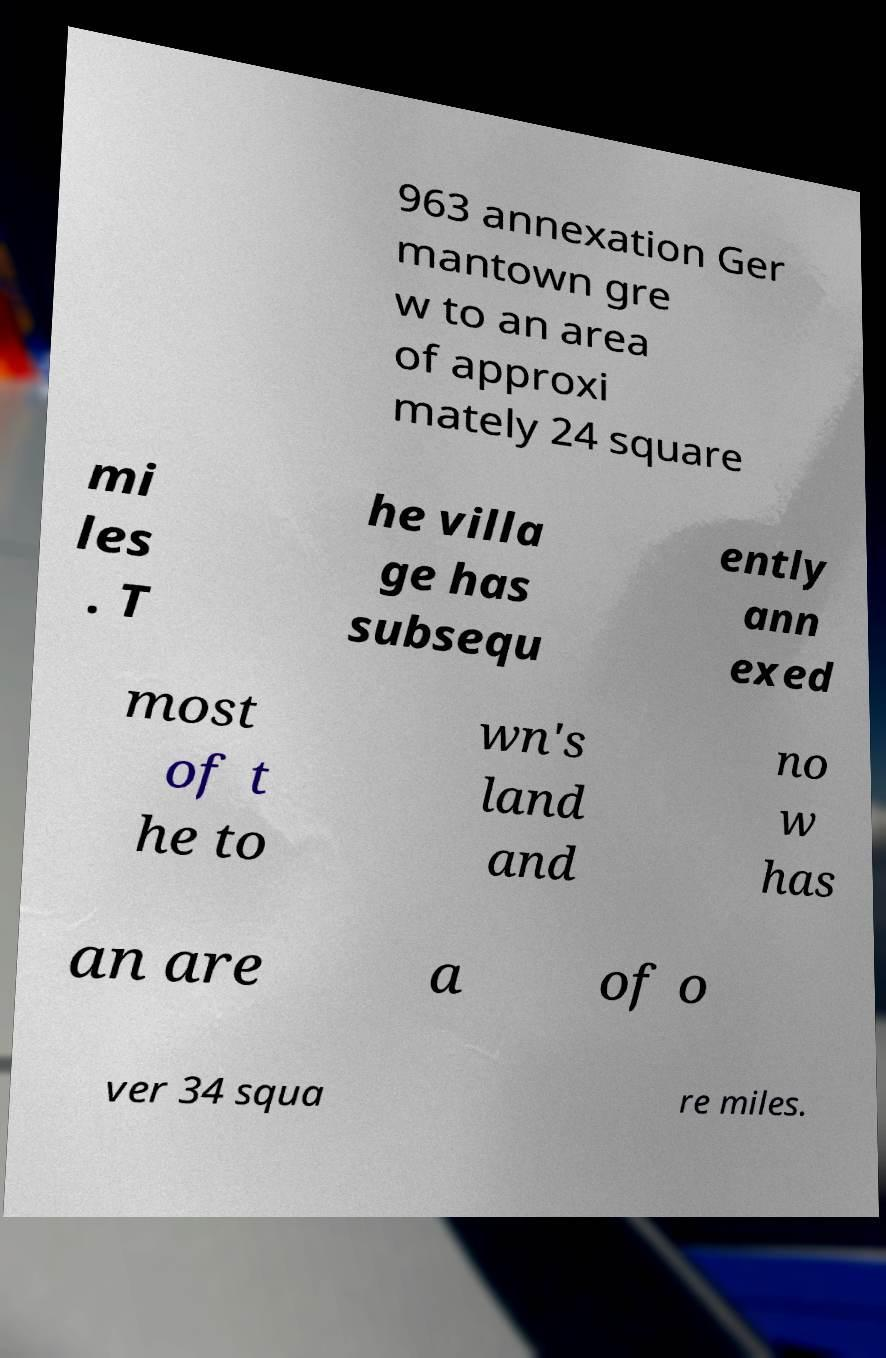Can you accurately transcribe the text from the provided image for me? 963 annexation Ger mantown gre w to an area of approxi mately 24 square mi les . T he villa ge has subsequ ently ann exed most of t he to wn's land and no w has an are a of o ver 34 squa re miles. 